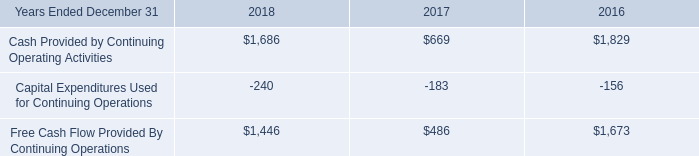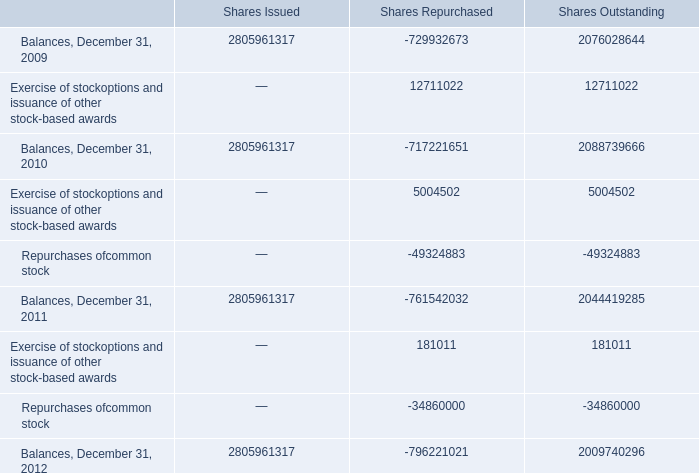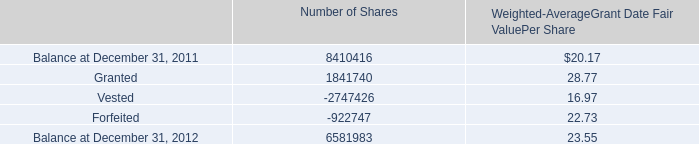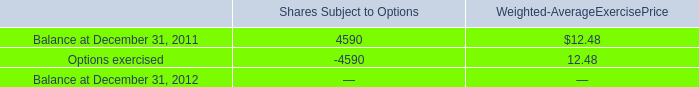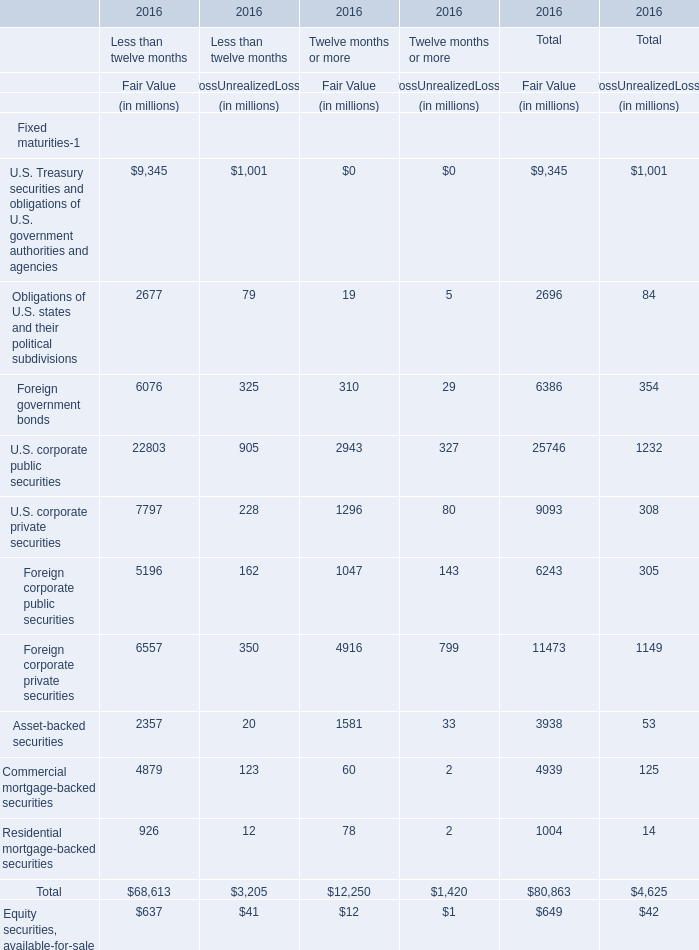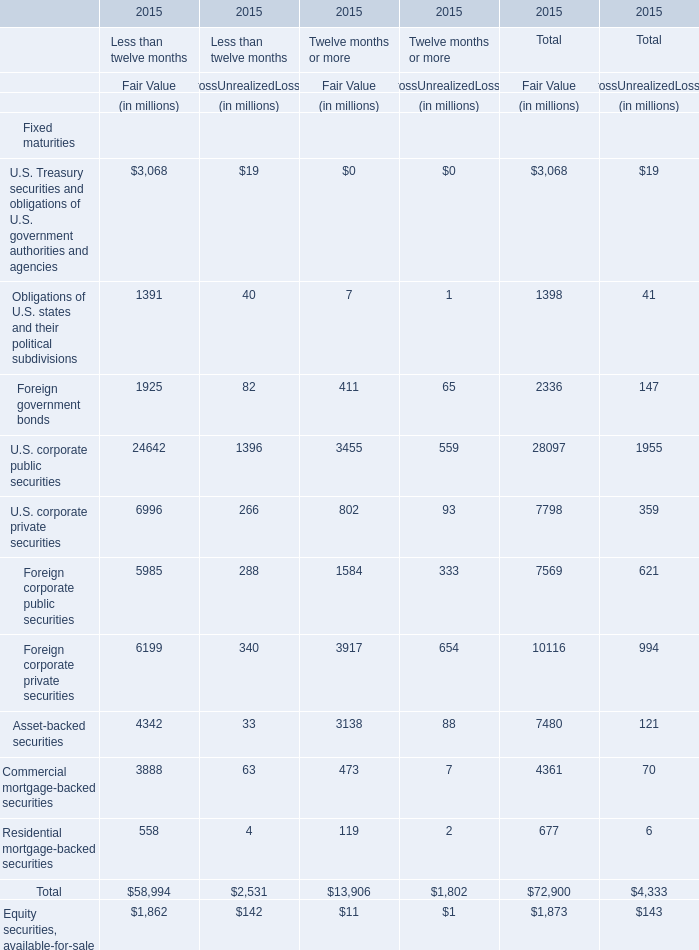What is the sum of Balances, December 31, 2010 of Shares Outstanding, and Balance at December 31, 2011 of Number of Shares ? 
Computations: (2088739666.0 + 8410416.0)
Answer: 2097150082.0. 